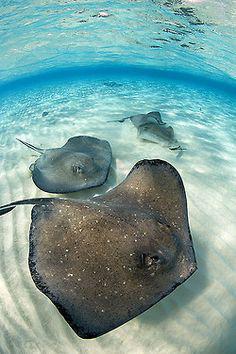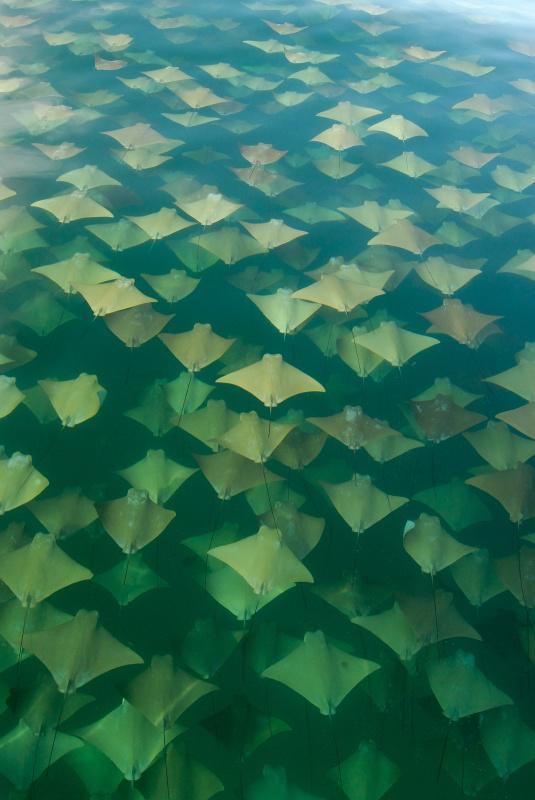The first image is the image on the left, the second image is the image on the right. Given the left and right images, does the statement "An image shows a mass of jellyfish along with something manmade that moves through the water." hold true? Answer yes or no. No. The first image is the image on the left, the second image is the image on the right. For the images shown, is this caption "A single ray is swimming near the sand in the image on the left." true? Answer yes or no. No. 